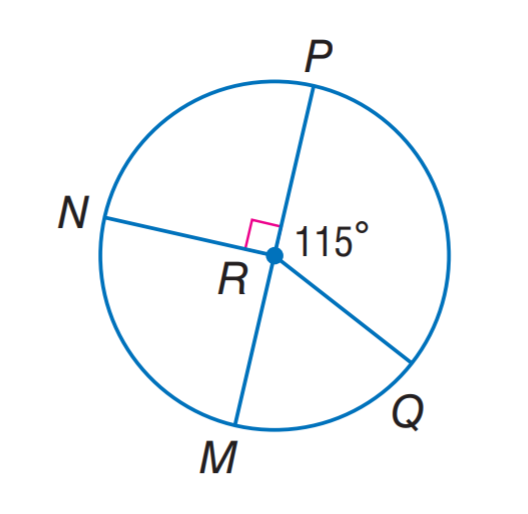Answer the mathemtical geometry problem and directly provide the correct option letter.
Question: P M is a diameter of \odot R. Find m \widehat M N P.
Choices: A: 120 B: 140 C: 160 D: 180 D 